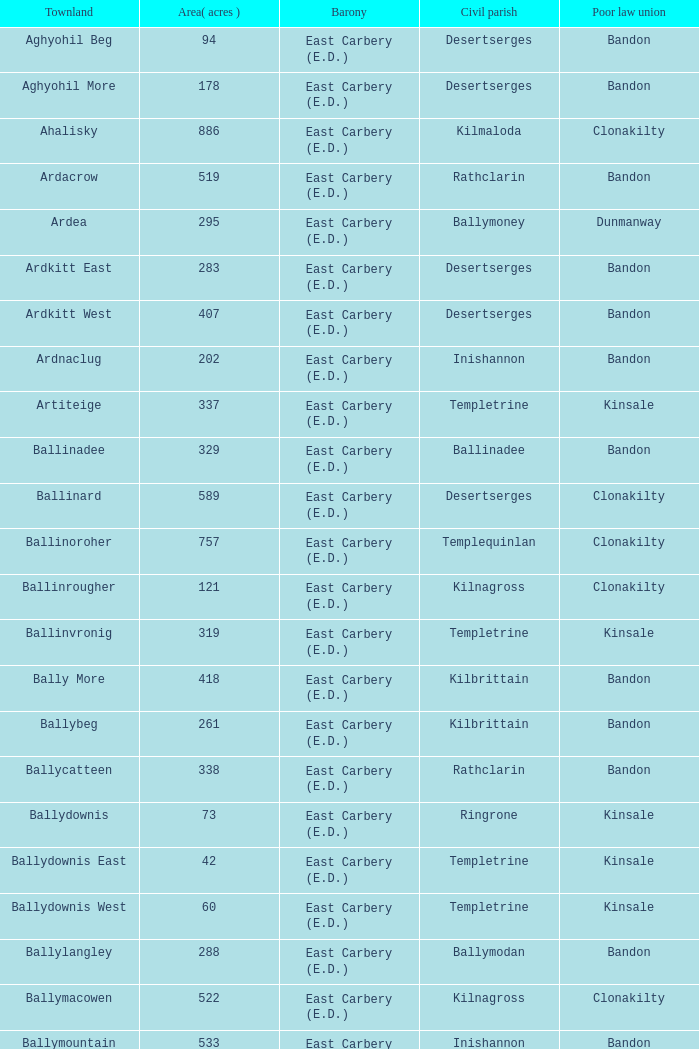What is the poor law union of the Kilmaloda townland? Clonakilty. 